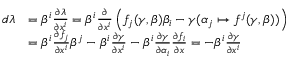Convert formula to latex. <formula><loc_0><loc_0><loc_500><loc_500>\begin{array} { r l } { d \lambda } & { = \beta ^ { i } \frac { \partial \lambda } { \partial x ^ { i } } = \beta ^ { i } \frac { \partial } { \partial x ^ { i } } \left ( f _ { j } ( \gamma , \beta ) \beta _ { i } - \gamma ( \alpha _ { j } \mapsto f ^ { j } ( \gamma , \beta ) ) \right ) } \\ & { = \beta ^ { i } \frac { \partial f _ { j } } { \partial x ^ { i } } \beta ^ { j } - \beta ^ { i } \frac { \partial \gamma } { \partial x ^ { i } } - \beta ^ { i } \frac { \partial \gamma } { \partial \alpha _ { i } } \frac { \partial f _ { i } } { \partial x } = - \beta ^ { i } \frac { \partial \gamma } { \partial x ^ { i } } } \end{array}</formula> 